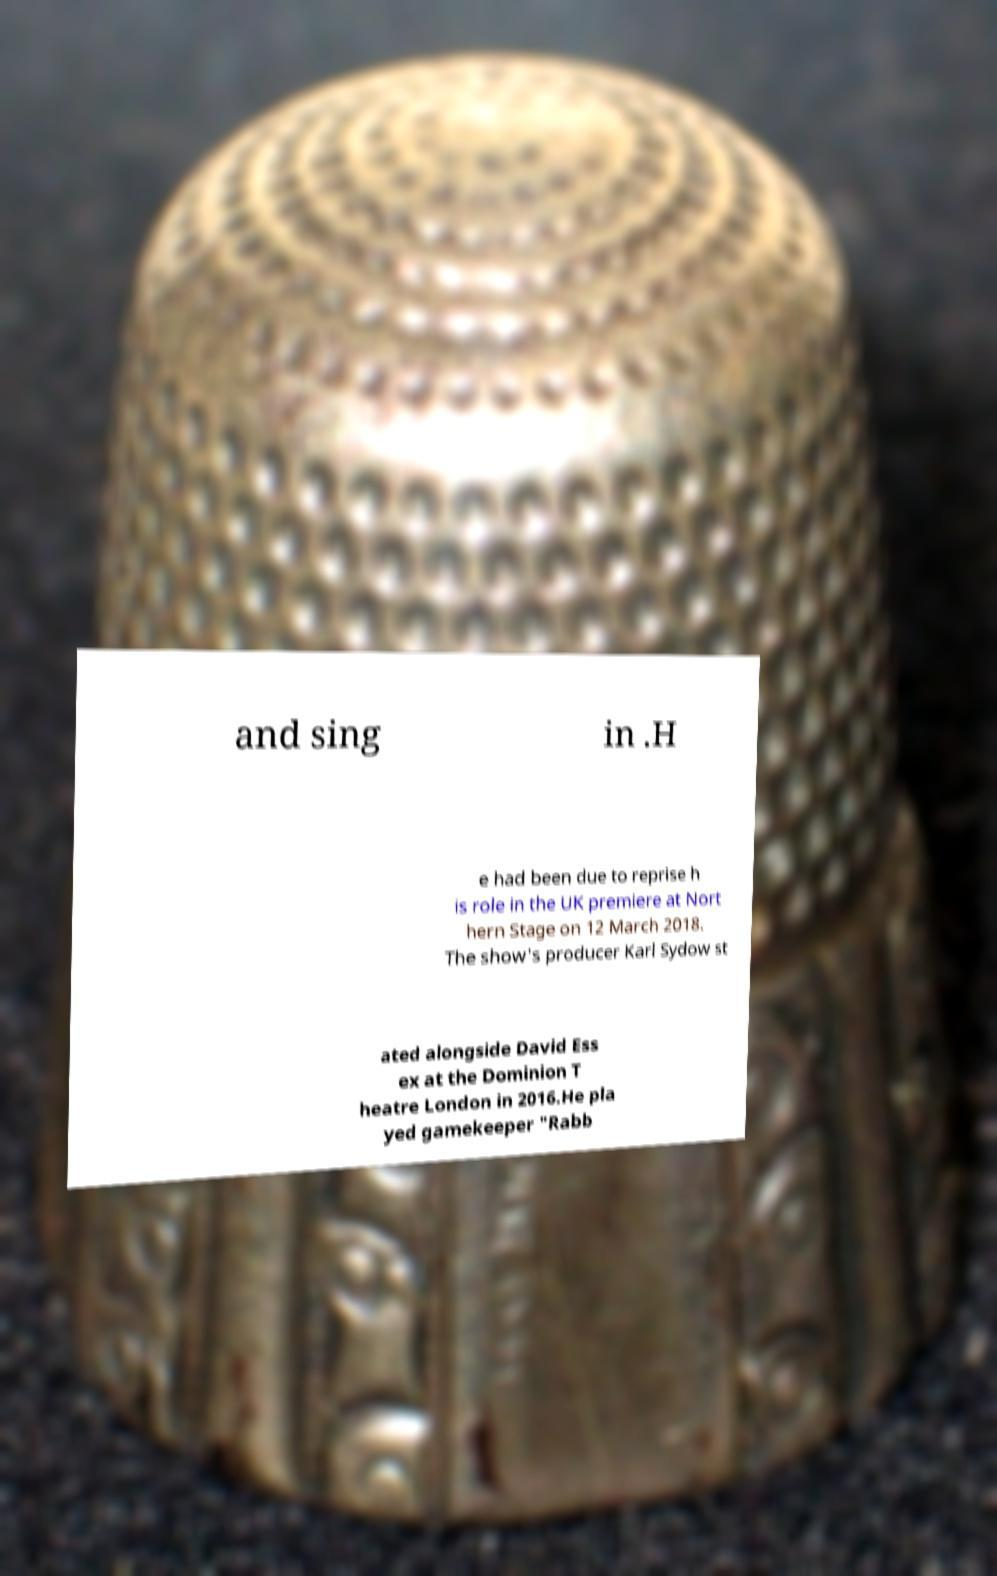Could you extract and type out the text from this image? and sing in .H e had been due to reprise h is role in the UK premiere at Nort hern Stage on 12 March 2018. The show's producer Karl Sydow st ated alongside David Ess ex at the Dominion T heatre London in 2016.He pla yed gamekeeper "Rabb 